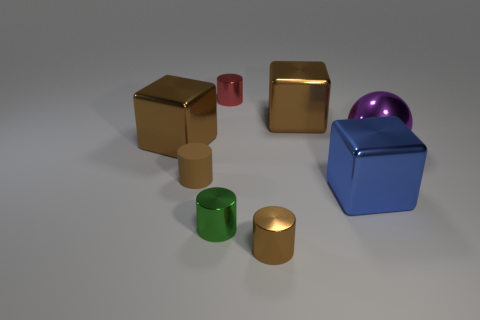Subtract all big brown shiny cubes. How many cubes are left? 1 Subtract all blue blocks. How many blocks are left? 2 Add 2 green metallic cylinders. How many objects exist? 10 Subtract all spheres. How many objects are left? 7 Subtract 0 gray cubes. How many objects are left? 8 Subtract 4 cylinders. How many cylinders are left? 0 Subtract all purple blocks. Subtract all cyan balls. How many blocks are left? 3 Subtract all blue cylinders. How many green cubes are left? 0 Subtract all big things. Subtract all tiny green shiny objects. How many objects are left? 3 Add 3 matte cylinders. How many matte cylinders are left? 4 